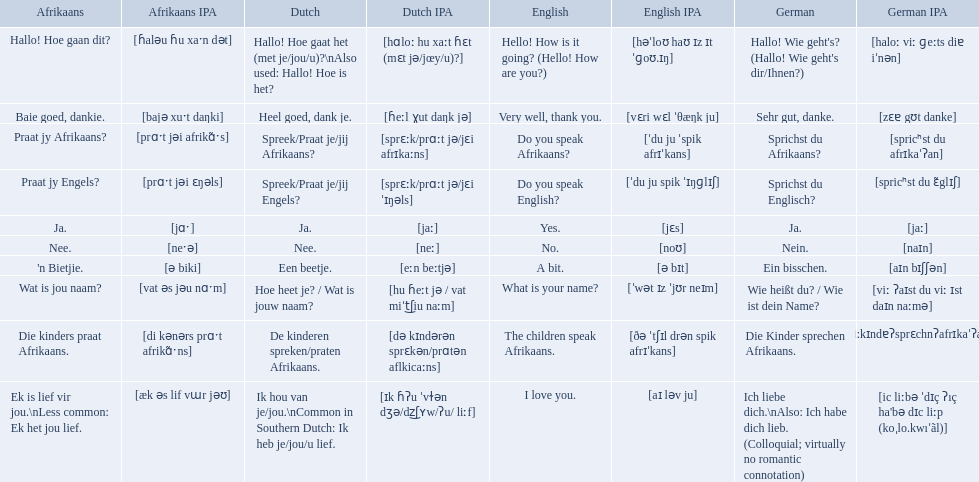In german how do you say do you speak afrikaans? Sprichst du Afrikaans?. How do you say it in afrikaans? Praat jy Afrikaans?. What are all of the afrikaans phrases shown in the table? Hallo! Hoe gaan dit?, Baie goed, dankie., Praat jy Afrikaans?, Praat jy Engels?, Ja., Nee., 'n Bietjie., Wat is jou naam?, Die kinders praat Afrikaans., Ek is lief vir jou.\nLess common: Ek het jou lief. Of those, which translates into english as do you speak afrikaans?? Praat jy Afrikaans?. What are all of the afrikaans phrases in the list? Hallo! Hoe gaan dit?, Baie goed, dankie., Praat jy Afrikaans?, Praat jy Engels?, Ja., Nee., 'n Bietjie., Wat is jou naam?, Die kinders praat Afrikaans., Ek is lief vir jou.\nLess common: Ek het jou lief. What is the english translation of each phrase? Hello! How is it going? (Hello! How are you?), Very well, thank you., Do you speak Afrikaans?, Do you speak English?, Yes., No., A bit., What is your name?, The children speak Afrikaans., I love you. And which afrikaans phrase translated to do you speak afrikaans? Praat jy Afrikaans?. 